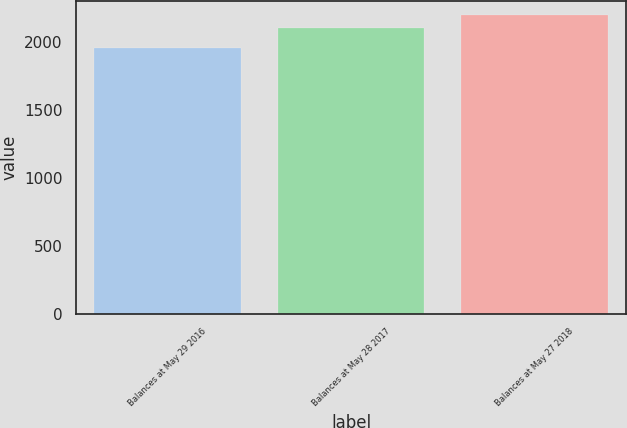Convert chart. <chart><loc_0><loc_0><loc_500><loc_500><bar_chart><fcel>Balances at May 29 2016<fcel>Balances at May 28 2017<fcel>Balances at May 27 2018<nl><fcel>1952<fcel>2101.7<fcel>2194.8<nl></chart> 